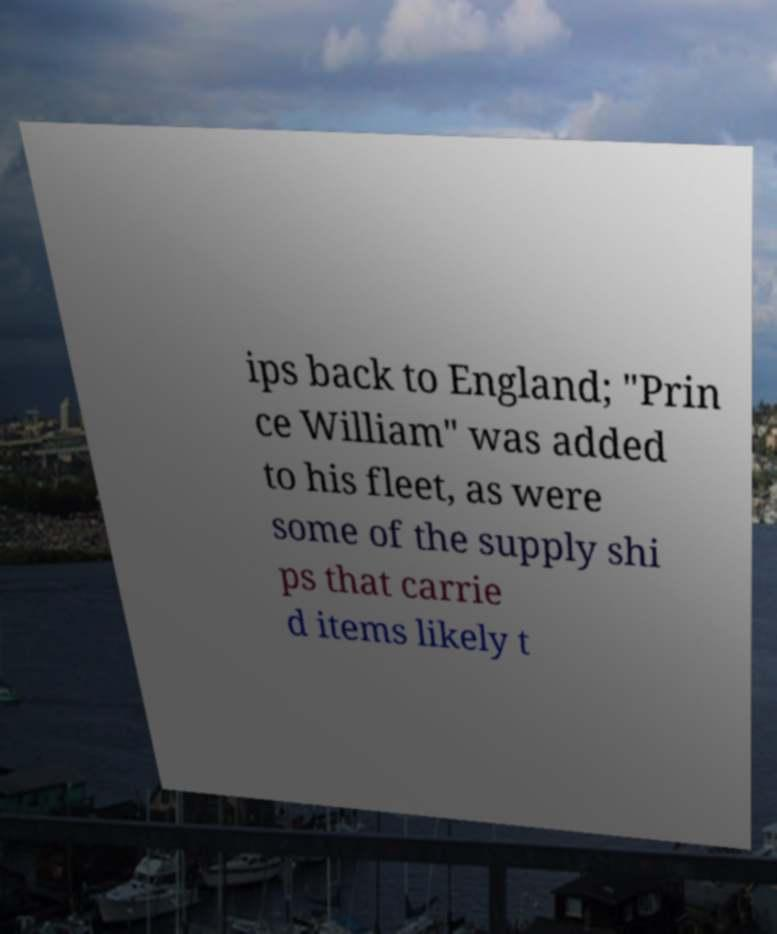Can you accurately transcribe the text from the provided image for me? ips back to England; "Prin ce William" was added to his fleet, as were some of the supply shi ps that carrie d items likely t 